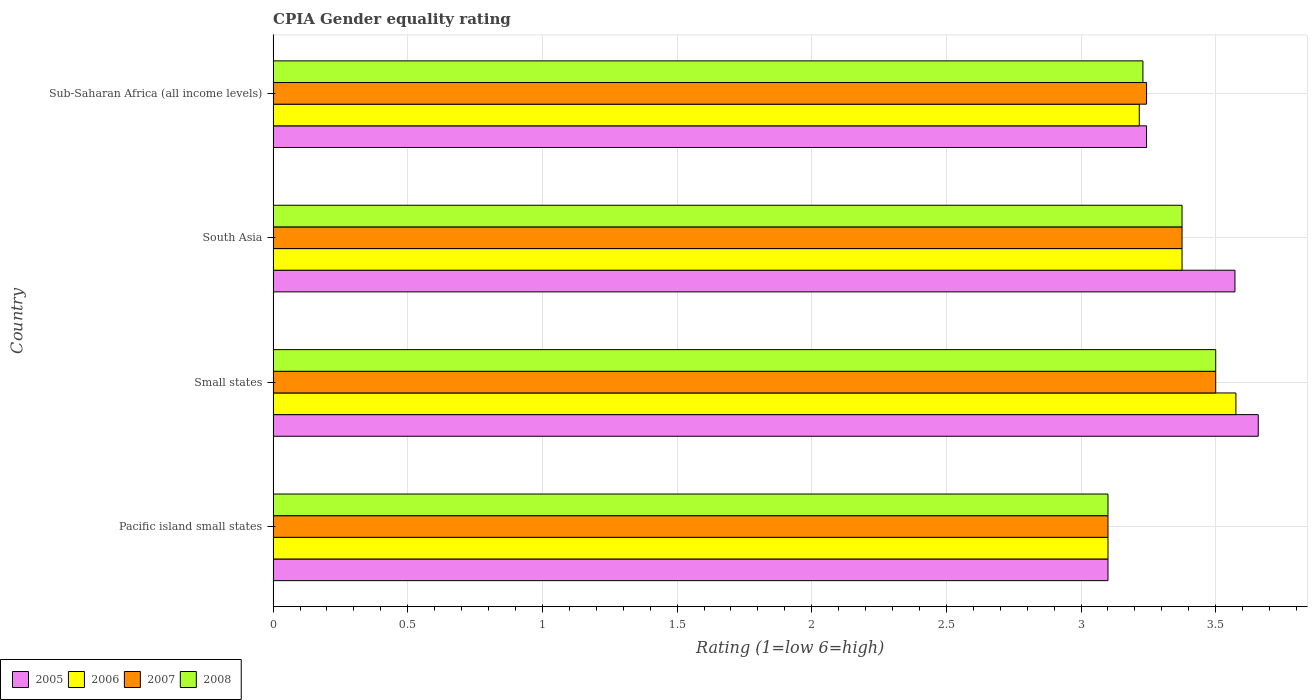How many different coloured bars are there?
Offer a very short reply. 4. Are the number of bars on each tick of the Y-axis equal?
Your response must be concise. Yes. How many bars are there on the 1st tick from the top?
Offer a terse response. 4. How many bars are there on the 1st tick from the bottom?
Provide a short and direct response. 4. What is the label of the 3rd group of bars from the top?
Keep it short and to the point. Small states. In how many cases, is the number of bars for a given country not equal to the number of legend labels?
Offer a terse response. 0. What is the CPIA rating in 2008 in Sub-Saharan Africa (all income levels)?
Provide a succinct answer. 3.23. Across all countries, what is the maximum CPIA rating in 2005?
Keep it short and to the point. 3.66. In which country was the CPIA rating in 2006 maximum?
Your response must be concise. Small states. In which country was the CPIA rating in 2005 minimum?
Offer a very short reply. Pacific island small states. What is the total CPIA rating in 2005 in the graph?
Offer a terse response. 13.57. What is the difference between the CPIA rating in 2006 in Small states and that in Sub-Saharan Africa (all income levels)?
Offer a terse response. 0.36. What is the difference between the CPIA rating in 2008 in Sub-Saharan Africa (all income levels) and the CPIA rating in 2005 in Pacific island small states?
Ensure brevity in your answer.  0.13. What is the average CPIA rating in 2008 per country?
Ensure brevity in your answer.  3.3. What is the difference between the CPIA rating in 2008 and CPIA rating in 2005 in Pacific island small states?
Give a very brief answer. 0. What is the ratio of the CPIA rating in 2007 in Small states to that in Sub-Saharan Africa (all income levels)?
Offer a very short reply. 1.08. Is the difference between the CPIA rating in 2008 in Small states and South Asia greater than the difference between the CPIA rating in 2005 in Small states and South Asia?
Make the answer very short. Yes. What is the difference between the highest and the second highest CPIA rating in 2005?
Provide a short and direct response. 0.09. What is the difference between the highest and the lowest CPIA rating in 2006?
Your response must be concise. 0.48. In how many countries, is the CPIA rating in 2007 greater than the average CPIA rating in 2007 taken over all countries?
Give a very brief answer. 2. Is the sum of the CPIA rating in 2008 in Pacific island small states and Sub-Saharan Africa (all income levels) greater than the maximum CPIA rating in 2006 across all countries?
Give a very brief answer. Yes. Is it the case that in every country, the sum of the CPIA rating in 2008 and CPIA rating in 2006 is greater than the sum of CPIA rating in 2005 and CPIA rating in 2007?
Offer a terse response. No. What does the 3rd bar from the top in Pacific island small states represents?
Keep it short and to the point. 2006. How many bars are there?
Keep it short and to the point. 16. Are all the bars in the graph horizontal?
Offer a terse response. Yes. Does the graph contain any zero values?
Your response must be concise. No. Does the graph contain grids?
Give a very brief answer. Yes. Where does the legend appear in the graph?
Provide a succinct answer. Bottom left. How many legend labels are there?
Provide a short and direct response. 4. What is the title of the graph?
Ensure brevity in your answer.  CPIA Gender equality rating. What is the label or title of the X-axis?
Make the answer very short. Rating (1=low 6=high). What is the label or title of the Y-axis?
Provide a short and direct response. Country. What is the Rating (1=low 6=high) of 2005 in Small states?
Provide a short and direct response. 3.66. What is the Rating (1=low 6=high) of 2006 in Small states?
Offer a very short reply. 3.58. What is the Rating (1=low 6=high) in 2005 in South Asia?
Make the answer very short. 3.57. What is the Rating (1=low 6=high) in 2006 in South Asia?
Make the answer very short. 3.38. What is the Rating (1=low 6=high) in 2007 in South Asia?
Your answer should be compact. 3.38. What is the Rating (1=low 6=high) in 2008 in South Asia?
Offer a terse response. 3.38. What is the Rating (1=low 6=high) in 2005 in Sub-Saharan Africa (all income levels)?
Your answer should be compact. 3.24. What is the Rating (1=low 6=high) in 2006 in Sub-Saharan Africa (all income levels)?
Provide a succinct answer. 3.22. What is the Rating (1=low 6=high) of 2007 in Sub-Saharan Africa (all income levels)?
Provide a succinct answer. 3.24. What is the Rating (1=low 6=high) in 2008 in Sub-Saharan Africa (all income levels)?
Your answer should be very brief. 3.23. Across all countries, what is the maximum Rating (1=low 6=high) in 2005?
Ensure brevity in your answer.  3.66. Across all countries, what is the maximum Rating (1=low 6=high) in 2006?
Your answer should be very brief. 3.58. Across all countries, what is the maximum Rating (1=low 6=high) of 2007?
Offer a very short reply. 3.5. Across all countries, what is the maximum Rating (1=low 6=high) of 2008?
Keep it short and to the point. 3.5. Across all countries, what is the minimum Rating (1=low 6=high) of 2005?
Offer a terse response. 3.1. Across all countries, what is the minimum Rating (1=low 6=high) of 2006?
Give a very brief answer. 3.1. Across all countries, what is the minimum Rating (1=low 6=high) of 2008?
Make the answer very short. 3.1. What is the total Rating (1=low 6=high) of 2005 in the graph?
Offer a terse response. 13.57. What is the total Rating (1=low 6=high) in 2006 in the graph?
Provide a succinct answer. 13.27. What is the total Rating (1=low 6=high) of 2007 in the graph?
Your answer should be very brief. 13.22. What is the total Rating (1=low 6=high) of 2008 in the graph?
Provide a succinct answer. 13.2. What is the difference between the Rating (1=low 6=high) in 2005 in Pacific island small states and that in Small states?
Provide a short and direct response. -0.56. What is the difference between the Rating (1=low 6=high) in 2006 in Pacific island small states and that in Small states?
Make the answer very short. -0.47. What is the difference between the Rating (1=low 6=high) of 2007 in Pacific island small states and that in Small states?
Your answer should be compact. -0.4. What is the difference between the Rating (1=low 6=high) in 2008 in Pacific island small states and that in Small states?
Make the answer very short. -0.4. What is the difference between the Rating (1=low 6=high) of 2005 in Pacific island small states and that in South Asia?
Ensure brevity in your answer.  -0.47. What is the difference between the Rating (1=low 6=high) in 2006 in Pacific island small states and that in South Asia?
Ensure brevity in your answer.  -0.28. What is the difference between the Rating (1=low 6=high) of 2007 in Pacific island small states and that in South Asia?
Ensure brevity in your answer.  -0.28. What is the difference between the Rating (1=low 6=high) of 2008 in Pacific island small states and that in South Asia?
Make the answer very short. -0.28. What is the difference between the Rating (1=low 6=high) of 2005 in Pacific island small states and that in Sub-Saharan Africa (all income levels)?
Your answer should be compact. -0.14. What is the difference between the Rating (1=low 6=high) in 2006 in Pacific island small states and that in Sub-Saharan Africa (all income levels)?
Keep it short and to the point. -0.12. What is the difference between the Rating (1=low 6=high) in 2007 in Pacific island small states and that in Sub-Saharan Africa (all income levels)?
Provide a short and direct response. -0.14. What is the difference between the Rating (1=low 6=high) of 2008 in Pacific island small states and that in Sub-Saharan Africa (all income levels)?
Offer a terse response. -0.13. What is the difference between the Rating (1=low 6=high) in 2005 in Small states and that in South Asia?
Ensure brevity in your answer.  0.09. What is the difference between the Rating (1=low 6=high) of 2006 in Small states and that in South Asia?
Ensure brevity in your answer.  0.2. What is the difference between the Rating (1=low 6=high) in 2008 in Small states and that in South Asia?
Offer a terse response. 0.12. What is the difference between the Rating (1=low 6=high) of 2005 in Small states and that in Sub-Saharan Africa (all income levels)?
Your response must be concise. 0.41. What is the difference between the Rating (1=low 6=high) of 2006 in Small states and that in Sub-Saharan Africa (all income levels)?
Keep it short and to the point. 0.36. What is the difference between the Rating (1=low 6=high) of 2007 in Small states and that in Sub-Saharan Africa (all income levels)?
Make the answer very short. 0.26. What is the difference between the Rating (1=low 6=high) in 2008 in Small states and that in Sub-Saharan Africa (all income levels)?
Your response must be concise. 0.27. What is the difference between the Rating (1=low 6=high) of 2005 in South Asia and that in Sub-Saharan Africa (all income levels)?
Your answer should be very brief. 0.33. What is the difference between the Rating (1=low 6=high) of 2006 in South Asia and that in Sub-Saharan Africa (all income levels)?
Ensure brevity in your answer.  0.16. What is the difference between the Rating (1=low 6=high) in 2007 in South Asia and that in Sub-Saharan Africa (all income levels)?
Make the answer very short. 0.13. What is the difference between the Rating (1=low 6=high) of 2008 in South Asia and that in Sub-Saharan Africa (all income levels)?
Make the answer very short. 0.15. What is the difference between the Rating (1=low 6=high) in 2005 in Pacific island small states and the Rating (1=low 6=high) in 2006 in Small states?
Your answer should be compact. -0.47. What is the difference between the Rating (1=low 6=high) in 2006 in Pacific island small states and the Rating (1=low 6=high) in 2008 in Small states?
Your answer should be very brief. -0.4. What is the difference between the Rating (1=low 6=high) in 2005 in Pacific island small states and the Rating (1=low 6=high) in 2006 in South Asia?
Make the answer very short. -0.28. What is the difference between the Rating (1=low 6=high) in 2005 in Pacific island small states and the Rating (1=low 6=high) in 2007 in South Asia?
Offer a very short reply. -0.28. What is the difference between the Rating (1=low 6=high) in 2005 in Pacific island small states and the Rating (1=low 6=high) in 2008 in South Asia?
Your answer should be compact. -0.28. What is the difference between the Rating (1=low 6=high) in 2006 in Pacific island small states and the Rating (1=low 6=high) in 2007 in South Asia?
Keep it short and to the point. -0.28. What is the difference between the Rating (1=low 6=high) in 2006 in Pacific island small states and the Rating (1=low 6=high) in 2008 in South Asia?
Ensure brevity in your answer.  -0.28. What is the difference between the Rating (1=low 6=high) of 2007 in Pacific island small states and the Rating (1=low 6=high) of 2008 in South Asia?
Offer a very short reply. -0.28. What is the difference between the Rating (1=low 6=high) in 2005 in Pacific island small states and the Rating (1=low 6=high) in 2006 in Sub-Saharan Africa (all income levels)?
Offer a very short reply. -0.12. What is the difference between the Rating (1=low 6=high) of 2005 in Pacific island small states and the Rating (1=low 6=high) of 2007 in Sub-Saharan Africa (all income levels)?
Provide a succinct answer. -0.14. What is the difference between the Rating (1=low 6=high) of 2005 in Pacific island small states and the Rating (1=low 6=high) of 2008 in Sub-Saharan Africa (all income levels)?
Your answer should be very brief. -0.13. What is the difference between the Rating (1=low 6=high) in 2006 in Pacific island small states and the Rating (1=low 6=high) in 2007 in Sub-Saharan Africa (all income levels)?
Provide a succinct answer. -0.14. What is the difference between the Rating (1=low 6=high) in 2006 in Pacific island small states and the Rating (1=low 6=high) in 2008 in Sub-Saharan Africa (all income levels)?
Offer a very short reply. -0.13. What is the difference between the Rating (1=low 6=high) in 2007 in Pacific island small states and the Rating (1=low 6=high) in 2008 in Sub-Saharan Africa (all income levels)?
Provide a succinct answer. -0.13. What is the difference between the Rating (1=low 6=high) in 2005 in Small states and the Rating (1=low 6=high) in 2006 in South Asia?
Your answer should be very brief. 0.28. What is the difference between the Rating (1=low 6=high) of 2005 in Small states and the Rating (1=low 6=high) of 2007 in South Asia?
Give a very brief answer. 0.28. What is the difference between the Rating (1=low 6=high) in 2005 in Small states and the Rating (1=low 6=high) in 2008 in South Asia?
Make the answer very short. 0.28. What is the difference between the Rating (1=low 6=high) of 2006 in Small states and the Rating (1=low 6=high) of 2007 in South Asia?
Ensure brevity in your answer.  0.2. What is the difference between the Rating (1=low 6=high) in 2007 in Small states and the Rating (1=low 6=high) in 2008 in South Asia?
Your answer should be compact. 0.12. What is the difference between the Rating (1=low 6=high) in 2005 in Small states and the Rating (1=low 6=high) in 2006 in Sub-Saharan Africa (all income levels)?
Keep it short and to the point. 0.44. What is the difference between the Rating (1=low 6=high) of 2005 in Small states and the Rating (1=low 6=high) of 2007 in Sub-Saharan Africa (all income levels)?
Provide a short and direct response. 0.41. What is the difference between the Rating (1=low 6=high) in 2005 in Small states and the Rating (1=low 6=high) in 2008 in Sub-Saharan Africa (all income levels)?
Provide a short and direct response. 0.43. What is the difference between the Rating (1=low 6=high) in 2006 in Small states and the Rating (1=low 6=high) in 2007 in Sub-Saharan Africa (all income levels)?
Provide a succinct answer. 0.33. What is the difference between the Rating (1=low 6=high) of 2006 in Small states and the Rating (1=low 6=high) of 2008 in Sub-Saharan Africa (all income levels)?
Give a very brief answer. 0.35. What is the difference between the Rating (1=low 6=high) of 2007 in Small states and the Rating (1=low 6=high) of 2008 in Sub-Saharan Africa (all income levels)?
Keep it short and to the point. 0.27. What is the difference between the Rating (1=low 6=high) of 2005 in South Asia and the Rating (1=low 6=high) of 2006 in Sub-Saharan Africa (all income levels)?
Keep it short and to the point. 0.36. What is the difference between the Rating (1=low 6=high) of 2005 in South Asia and the Rating (1=low 6=high) of 2007 in Sub-Saharan Africa (all income levels)?
Your answer should be very brief. 0.33. What is the difference between the Rating (1=low 6=high) of 2005 in South Asia and the Rating (1=low 6=high) of 2008 in Sub-Saharan Africa (all income levels)?
Your answer should be compact. 0.34. What is the difference between the Rating (1=low 6=high) of 2006 in South Asia and the Rating (1=low 6=high) of 2007 in Sub-Saharan Africa (all income levels)?
Offer a very short reply. 0.13. What is the difference between the Rating (1=low 6=high) of 2006 in South Asia and the Rating (1=low 6=high) of 2008 in Sub-Saharan Africa (all income levels)?
Ensure brevity in your answer.  0.15. What is the difference between the Rating (1=low 6=high) of 2007 in South Asia and the Rating (1=low 6=high) of 2008 in Sub-Saharan Africa (all income levels)?
Ensure brevity in your answer.  0.15. What is the average Rating (1=low 6=high) of 2005 per country?
Your response must be concise. 3.39. What is the average Rating (1=low 6=high) in 2006 per country?
Keep it short and to the point. 3.32. What is the average Rating (1=low 6=high) in 2007 per country?
Offer a terse response. 3.3. What is the average Rating (1=low 6=high) of 2008 per country?
Your answer should be compact. 3.3. What is the difference between the Rating (1=low 6=high) of 2005 and Rating (1=low 6=high) of 2006 in Pacific island small states?
Keep it short and to the point. 0. What is the difference between the Rating (1=low 6=high) in 2005 and Rating (1=low 6=high) in 2007 in Pacific island small states?
Give a very brief answer. 0. What is the difference between the Rating (1=low 6=high) of 2006 and Rating (1=low 6=high) of 2008 in Pacific island small states?
Offer a terse response. 0. What is the difference between the Rating (1=low 6=high) of 2007 and Rating (1=low 6=high) of 2008 in Pacific island small states?
Your response must be concise. 0. What is the difference between the Rating (1=low 6=high) in 2005 and Rating (1=low 6=high) in 2006 in Small states?
Your answer should be very brief. 0.08. What is the difference between the Rating (1=low 6=high) in 2005 and Rating (1=low 6=high) in 2007 in Small states?
Provide a succinct answer. 0.16. What is the difference between the Rating (1=low 6=high) in 2005 and Rating (1=low 6=high) in 2008 in Small states?
Give a very brief answer. 0.16. What is the difference between the Rating (1=low 6=high) of 2006 and Rating (1=low 6=high) of 2007 in Small states?
Your response must be concise. 0.07. What is the difference between the Rating (1=low 6=high) of 2006 and Rating (1=low 6=high) of 2008 in Small states?
Offer a terse response. 0.07. What is the difference between the Rating (1=low 6=high) in 2005 and Rating (1=low 6=high) in 2006 in South Asia?
Your answer should be very brief. 0.2. What is the difference between the Rating (1=low 6=high) of 2005 and Rating (1=low 6=high) of 2007 in South Asia?
Your answer should be compact. 0.2. What is the difference between the Rating (1=low 6=high) in 2005 and Rating (1=low 6=high) in 2008 in South Asia?
Keep it short and to the point. 0.2. What is the difference between the Rating (1=low 6=high) in 2007 and Rating (1=low 6=high) in 2008 in South Asia?
Make the answer very short. 0. What is the difference between the Rating (1=low 6=high) of 2005 and Rating (1=low 6=high) of 2006 in Sub-Saharan Africa (all income levels)?
Provide a succinct answer. 0.03. What is the difference between the Rating (1=low 6=high) of 2005 and Rating (1=low 6=high) of 2008 in Sub-Saharan Africa (all income levels)?
Your response must be concise. 0.01. What is the difference between the Rating (1=low 6=high) of 2006 and Rating (1=low 6=high) of 2007 in Sub-Saharan Africa (all income levels)?
Keep it short and to the point. -0.03. What is the difference between the Rating (1=low 6=high) of 2006 and Rating (1=low 6=high) of 2008 in Sub-Saharan Africa (all income levels)?
Offer a very short reply. -0.01. What is the difference between the Rating (1=low 6=high) in 2007 and Rating (1=low 6=high) in 2008 in Sub-Saharan Africa (all income levels)?
Ensure brevity in your answer.  0.01. What is the ratio of the Rating (1=low 6=high) of 2005 in Pacific island small states to that in Small states?
Offer a very short reply. 0.85. What is the ratio of the Rating (1=low 6=high) in 2006 in Pacific island small states to that in Small states?
Your response must be concise. 0.87. What is the ratio of the Rating (1=low 6=high) in 2007 in Pacific island small states to that in Small states?
Provide a short and direct response. 0.89. What is the ratio of the Rating (1=low 6=high) of 2008 in Pacific island small states to that in Small states?
Make the answer very short. 0.89. What is the ratio of the Rating (1=low 6=high) in 2005 in Pacific island small states to that in South Asia?
Your response must be concise. 0.87. What is the ratio of the Rating (1=low 6=high) of 2006 in Pacific island small states to that in South Asia?
Make the answer very short. 0.92. What is the ratio of the Rating (1=low 6=high) in 2007 in Pacific island small states to that in South Asia?
Ensure brevity in your answer.  0.92. What is the ratio of the Rating (1=low 6=high) in 2008 in Pacific island small states to that in South Asia?
Provide a short and direct response. 0.92. What is the ratio of the Rating (1=low 6=high) in 2005 in Pacific island small states to that in Sub-Saharan Africa (all income levels)?
Provide a succinct answer. 0.96. What is the ratio of the Rating (1=low 6=high) in 2006 in Pacific island small states to that in Sub-Saharan Africa (all income levels)?
Your response must be concise. 0.96. What is the ratio of the Rating (1=low 6=high) of 2007 in Pacific island small states to that in Sub-Saharan Africa (all income levels)?
Your answer should be very brief. 0.96. What is the ratio of the Rating (1=low 6=high) in 2008 in Pacific island small states to that in Sub-Saharan Africa (all income levels)?
Ensure brevity in your answer.  0.96. What is the ratio of the Rating (1=low 6=high) in 2005 in Small states to that in South Asia?
Offer a very short reply. 1.02. What is the ratio of the Rating (1=low 6=high) in 2006 in Small states to that in South Asia?
Give a very brief answer. 1.06. What is the ratio of the Rating (1=low 6=high) in 2007 in Small states to that in South Asia?
Make the answer very short. 1.04. What is the ratio of the Rating (1=low 6=high) of 2008 in Small states to that in South Asia?
Offer a very short reply. 1.04. What is the ratio of the Rating (1=low 6=high) of 2005 in Small states to that in Sub-Saharan Africa (all income levels)?
Make the answer very short. 1.13. What is the ratio of the Rating (1=low 6=high) in 2006 in Small states to that in Sub-Saharan Africa (all income levels)?
Provide a short and direct response. 1.11. What is the ratio of the Rating (1=low 6=high) in 2007 in Small states to that in Sub-Saharan Africa (all income levels)?
Provide a succinct answer. 1.08. What is the ratio of the Rating (1=low 6=high) in 2008 in Small states to that in Sub-Saharan Africa (all income levels)?
Provide a succinct answer. 1.08. What is the ratio of the Rating (1=low 6=high) in 2005 in South Asia to that in Sub-Saharan Africa (all income levels)?
Offer a very short reply. 1.1. What is the ratio of the Rating (1=low 6=high) in 2006 in South Asia to that in Sub-Saharan Africa (all income levels)?
Provide a succinct answer. 1.05. What is the ratio of the Rating (1=low 6=high) in 2007 in South Asia to that in Sub-Saharan Africa (all income levels)?
Your answer should be compact. 1.04. What is the ratio of the Rating (1=low 6=high) of 2008 in South Asia to that in Sub-Saharan Africa (all income levels)?
Your answer should be very brief. 1.04. What is the difference between the highest and the second highest Rating (1=low 6=high) in 2005?
Offer a very short reply. 0.09. What is the difference between the highest and the second highest Rating (1=low 6=high) in 2007?
Your answer should be compact. 0.12. What is the difference between the highest and the lowest Rating (1=low 6=high) of 2005?
Offer a terse response. 0.56. What is the difference between the highest and the lowest Rating (1=low 6=high) of 2006?
Your answer should be very brief. 0.47. What is the difference between the highest and the lowest Rating (1=low 6=high) in 2007?
Offer a very short reply. 0.4. What is the difference between the highest and the lowest Rating (1=low 6=high) of 2008?
Offer a very short reply. 0.4. 